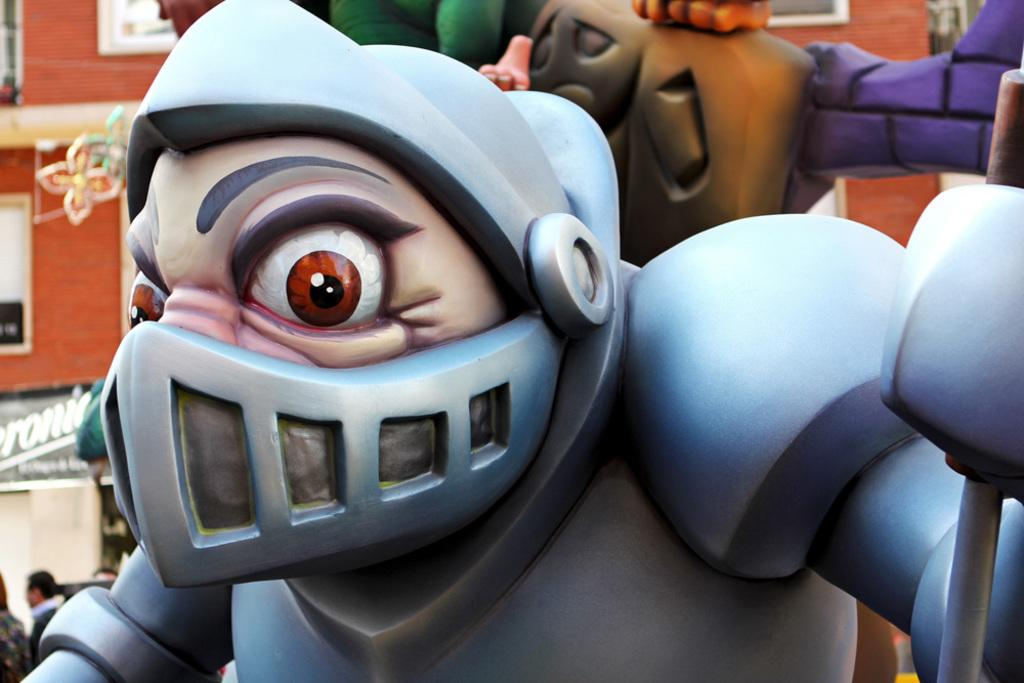What objects can be seen in the image that are typically associated with play? There are toys in the image. What type of structure is visible in the image? There is a building in the image. Who is present in the image? There is a man in the image. Can you tell me how deep the water is in the image? There is no water present in the image. Is there a slope visible in the image? There is no slope visible in the image. What type of war is depicted in the image? There is no war depicted in the image. 